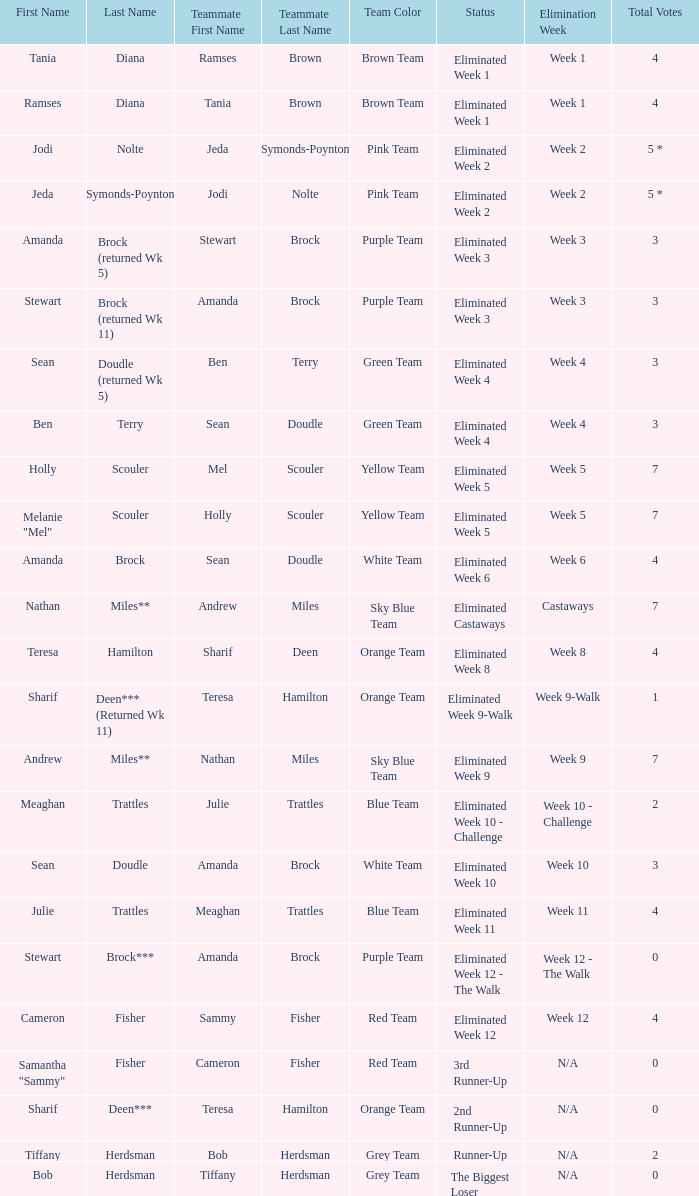What were Holly Scouler's total votes? 7.0. 